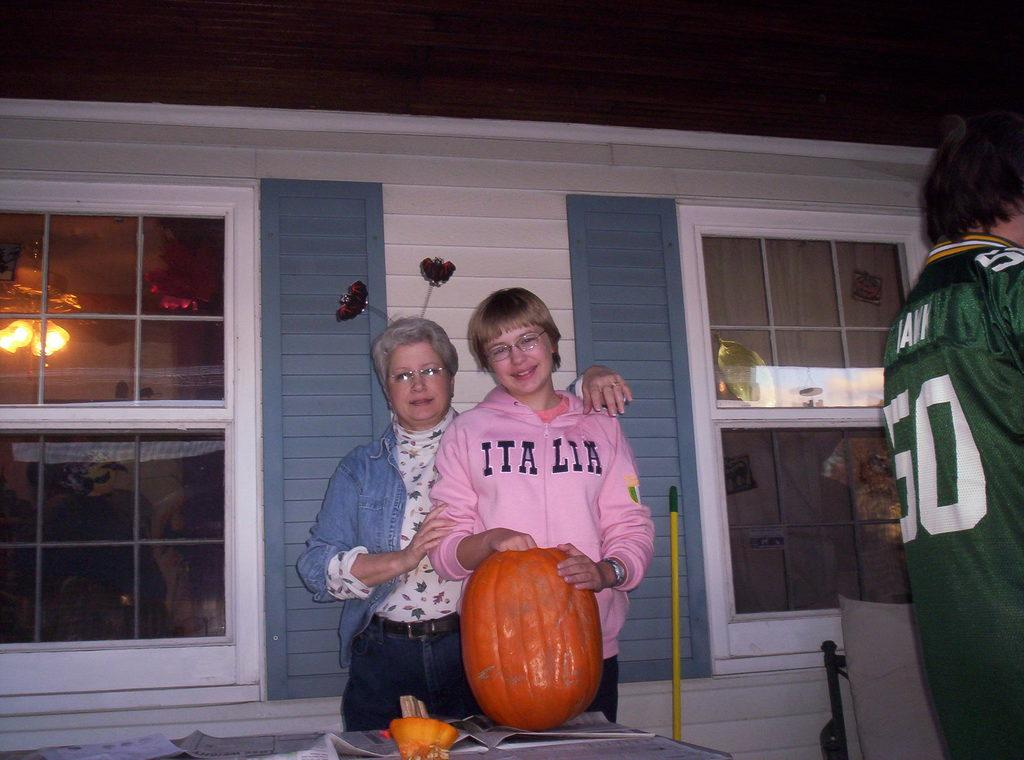Provide a one-sentence caption for the provided image. Girl wearing a pink hoodie that says Italia on it next to a pumpkin. 